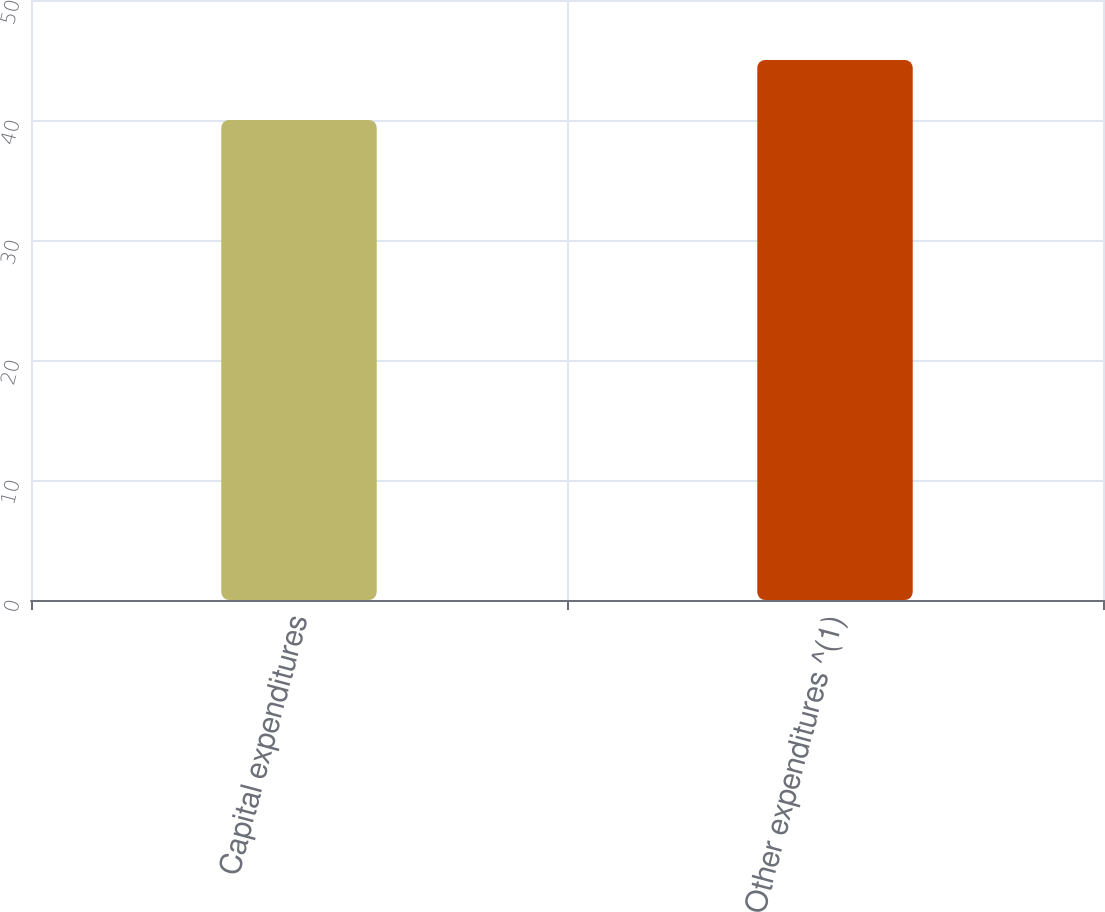Convert chart. <chart><loc_0><loc_0><loc_500><loc_500><bar_chart><fcel>Capital expenditures<fcel>Other expenditures ^(1)<nl><fcel>40<fcel>45<nl></chart> 